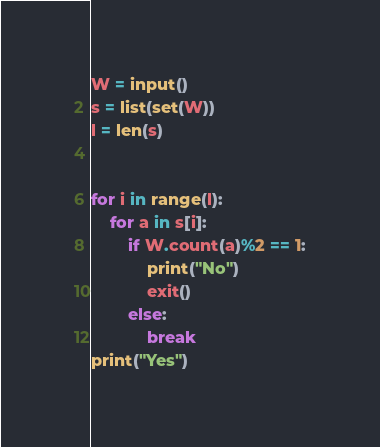Convert code to text. <code><loc_0><loc_0><loc_500><loc_500><_Python_>W = input()
s = list(set(W))
l = len(s)


for i in range(l):
    for a in s[i]:
        if W.count(a)%2 == 1:
            print("No")
            exit()
        else:
            break
print("Yes")
</code> 